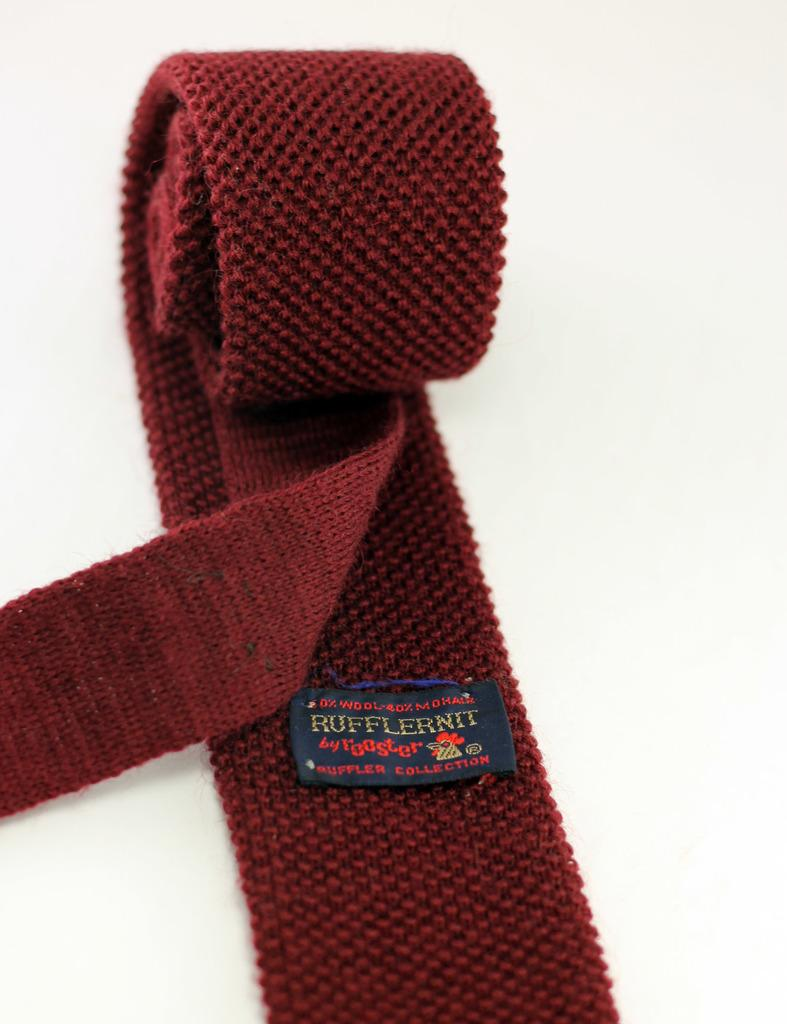What object in the image resembles a belt? There is an object in the image that resembles a belt. What color is the background of the image? The background of the image is white. What type of steel is used to make the throne in the image? There is no throne present in the image, and therefore no steel can be associated with it. 